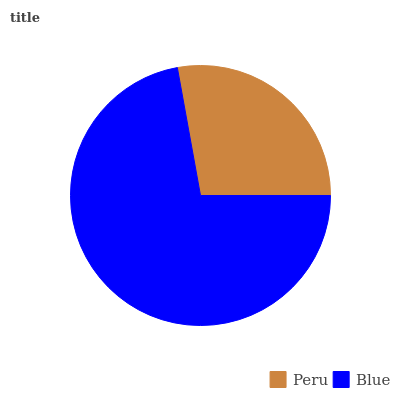Is Peru the minimum?
Answer yes or no. Yes. Is Blue the maximum?
Answer yes or no. Yes. Is Blue the minimum?
Answer yes or no. No. Is Blue greater than Peru?
Answer yes or no. Yes. Is Peru less than Blue?
Answer yes or no. Yes. Is Peru greater than Blue?
Answer yes or no. No. Is Blue less than Peru?
Answer yes or no. No. Is Blue the high median?
Answer yes or no. Yes. Is Peru the low median?
Answer yes or no. Yes. Is Peru the high median?
Answer yes or no. No. Is Blue the low median?
Answer yes or no. No. 